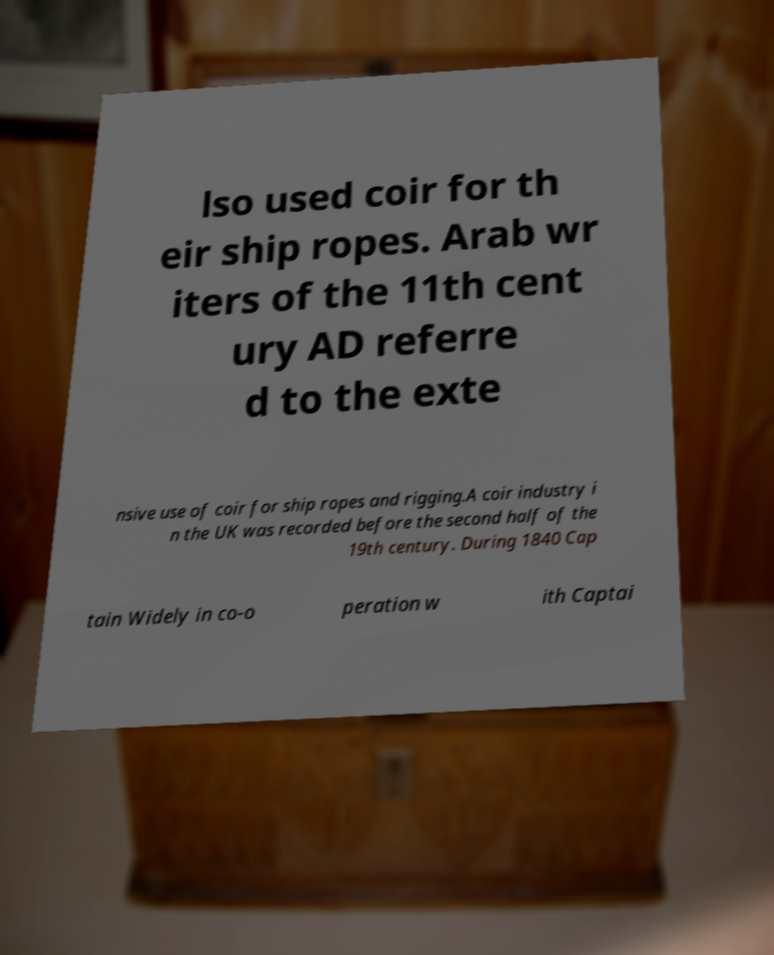For documentation purposes, I need the text within this image transcribed. Could you provide that? lso used coir for th eir ship ropes. Arab wr iters of the 11th cent ury AD referre d to the exte nsive use of coir for ship ropes and rigging.A coir industry i n the UK was recorded before the second half of the 19th century. During 1840 Cap tain Widely in co-o peration w ith Captai 